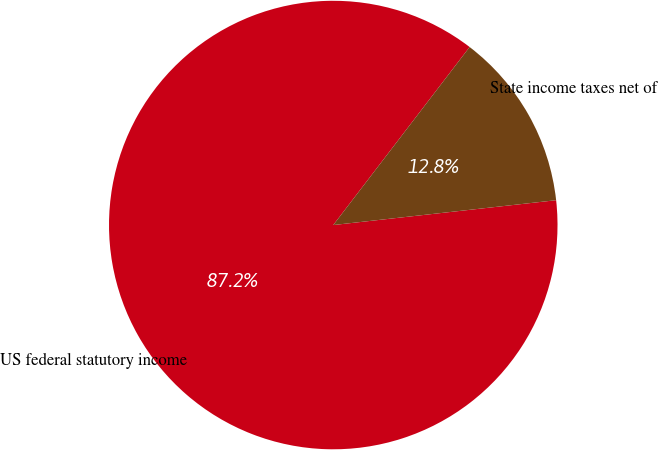<chart> <loc_0><loc_0><loc_500><loc_500><pie_chart><fcel>US federal statutory income<fcel>State income taxes net of<nl><fcel>87.17%<fcel>12.83%<nl></chart> 